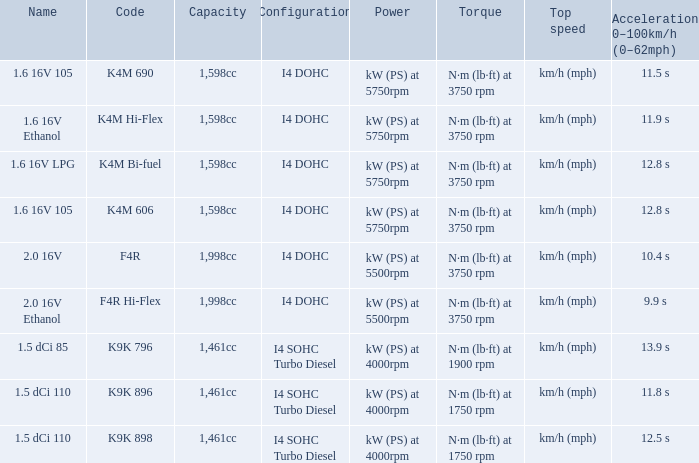What is the code of 1.5 dci 110, which has a capacity of 1,461cc? K9K 896, K9K 898. 